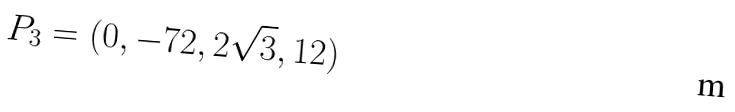Convert formula to latex. <formula><loc_0><loc_0><loc_500><loc_500>P _ { 3 } = ( 0 , - 7 2 , 2 \sqrt { 3 } , 1 2 )</formula> 